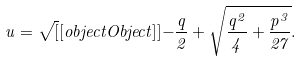Convert formula to latex. <formula><loc_0><loc_0><loc_500><loc_500>u = { \sqrt { [ } [ o b j e c t O b j e c t ] ] { - { \frac { q } { 2 } } + { \sqrt { { \frac { q ^ { 2 } } { 4 } } + { \frac { p ^ { 3 } } { 2 7 } } } } } } .</formula> 